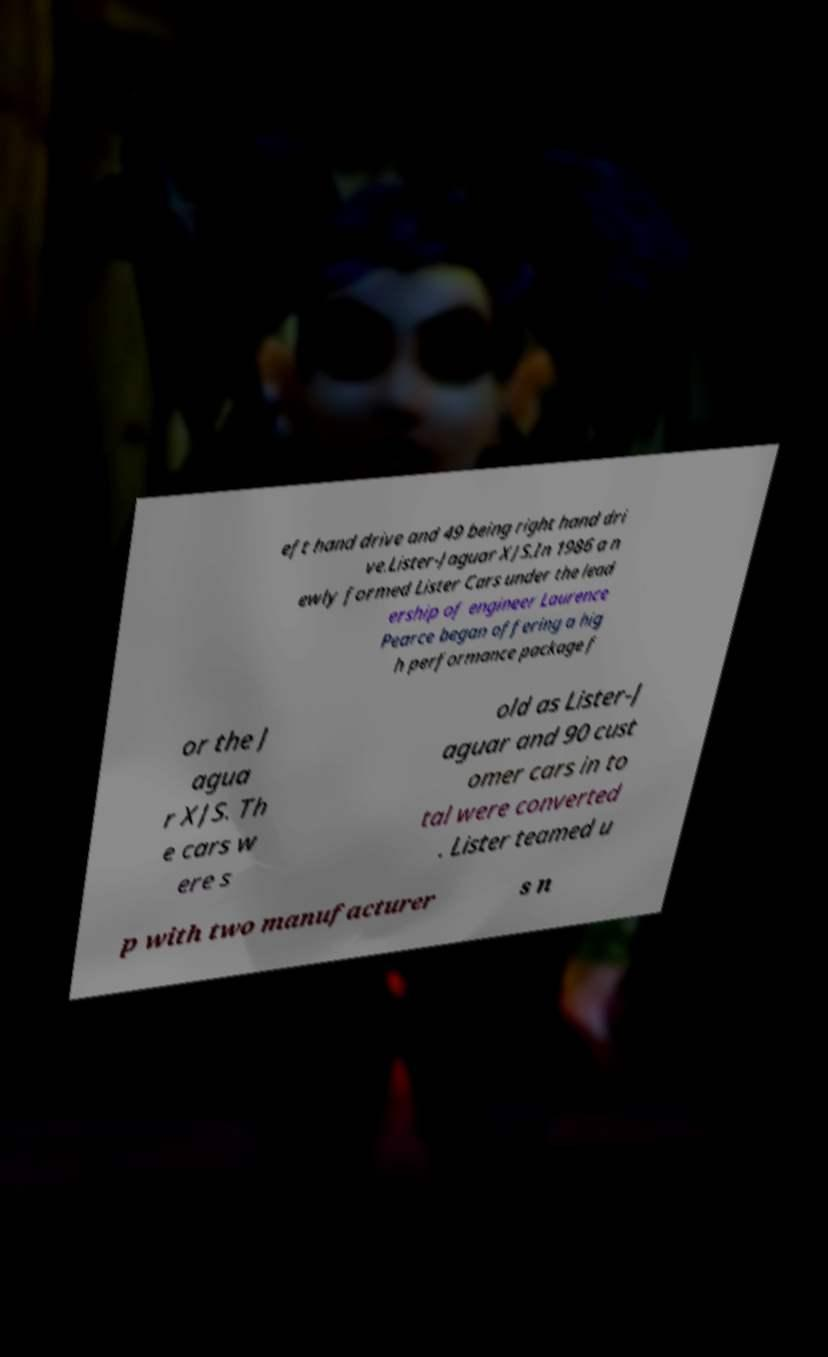Could you extract and type out the text from this image? eft hand drive and 49 being right hand dri ve.Lister-Jaguar XJS.In 1986 a n ewly formed Lister Cars under the lead ership of engineer Laurence Pearce began offering a hig h performance package f or the J agua r XJS. Th e cars w ere s old as Lister-J aguar and 90 cust omer cars in to tal were converted . Lister teamed u p with two manufacturer s n 